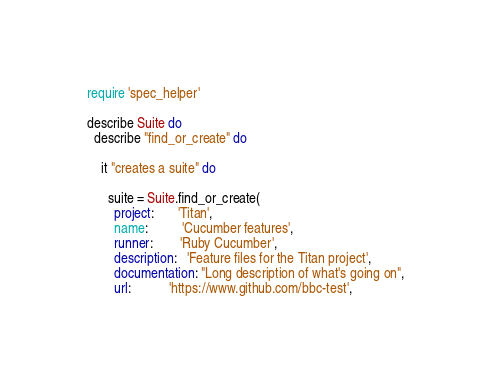<code> <loc_0><loc_0><loc_500><loc_500><_Ruby_>require 'spec_helper'

describe Suite do
  describe "find_or_create" do

    it "creates a suite" do
      
      suite = Suite.find_or_create(
        project:       'Titan',
        name:          'Cucumber features',
        runner:        'Ruby Cucumber',
        description:   'Feature files for the Titan project',
        documentation: "Long description of what's going on",
        url:           'https://www.github.com/bbc-test',</code> 